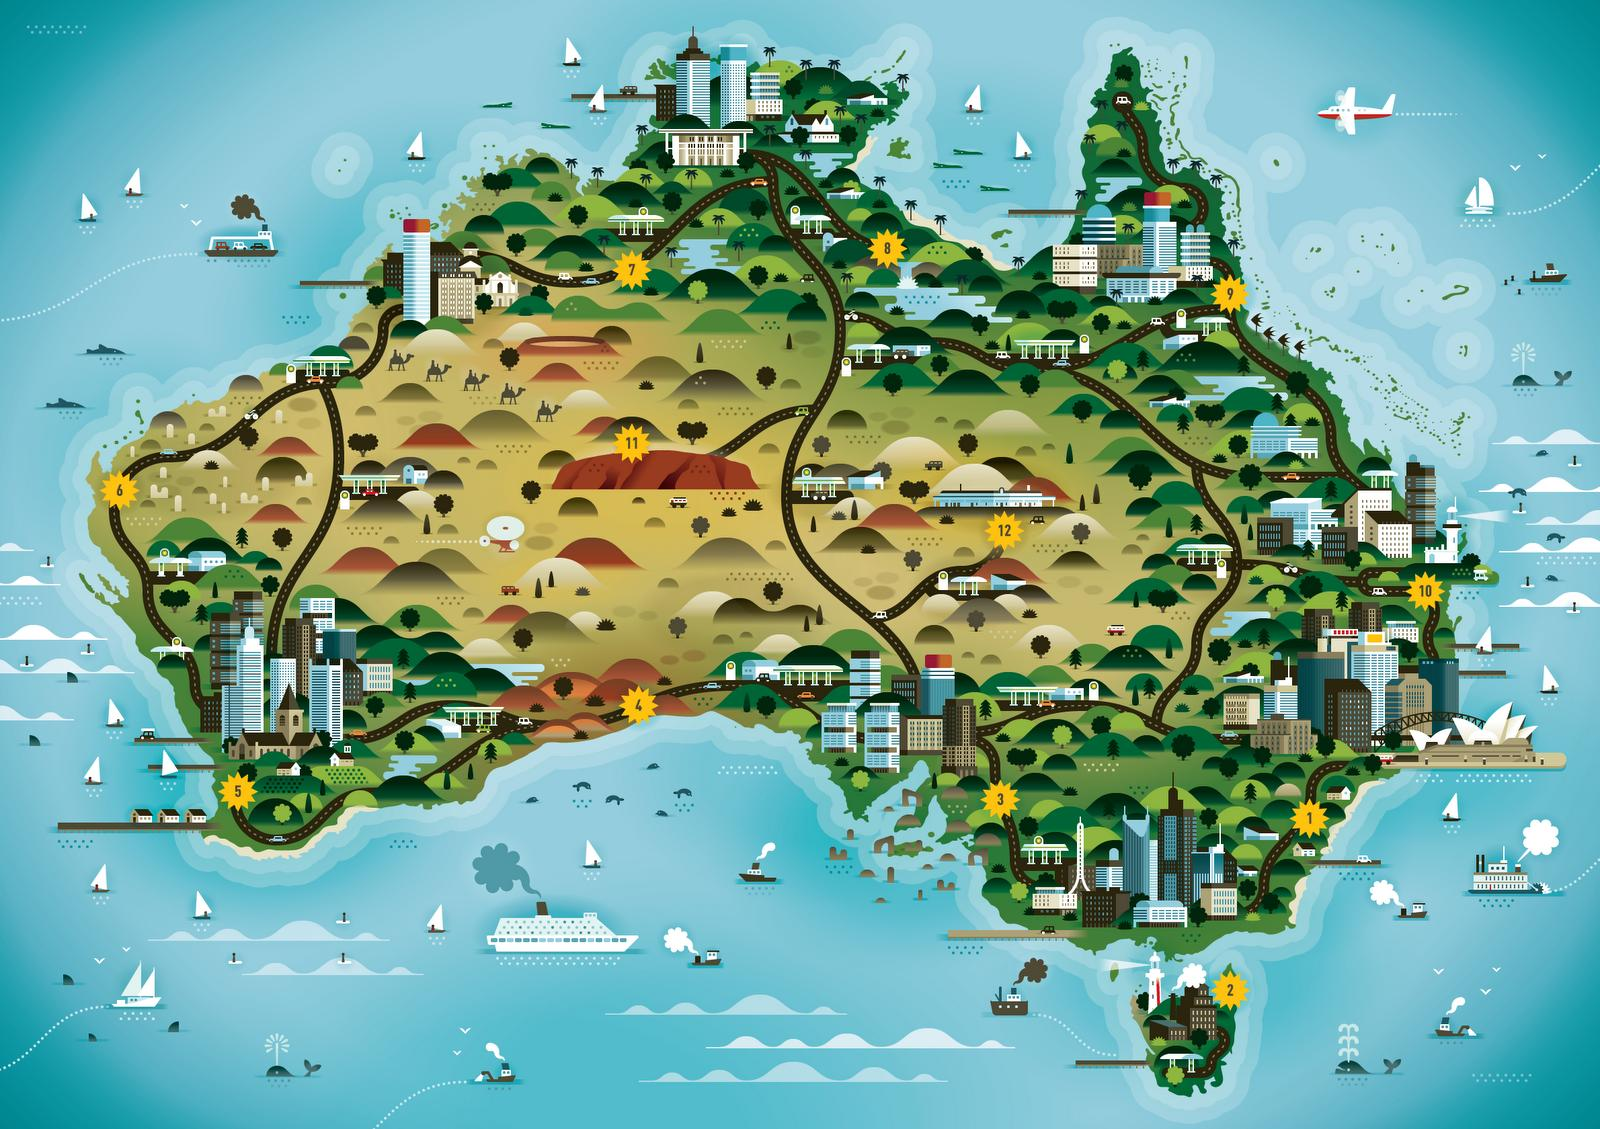Highlight a few significant elements in this photo. The map displays 12 regions. The information graphic shows five camels. 